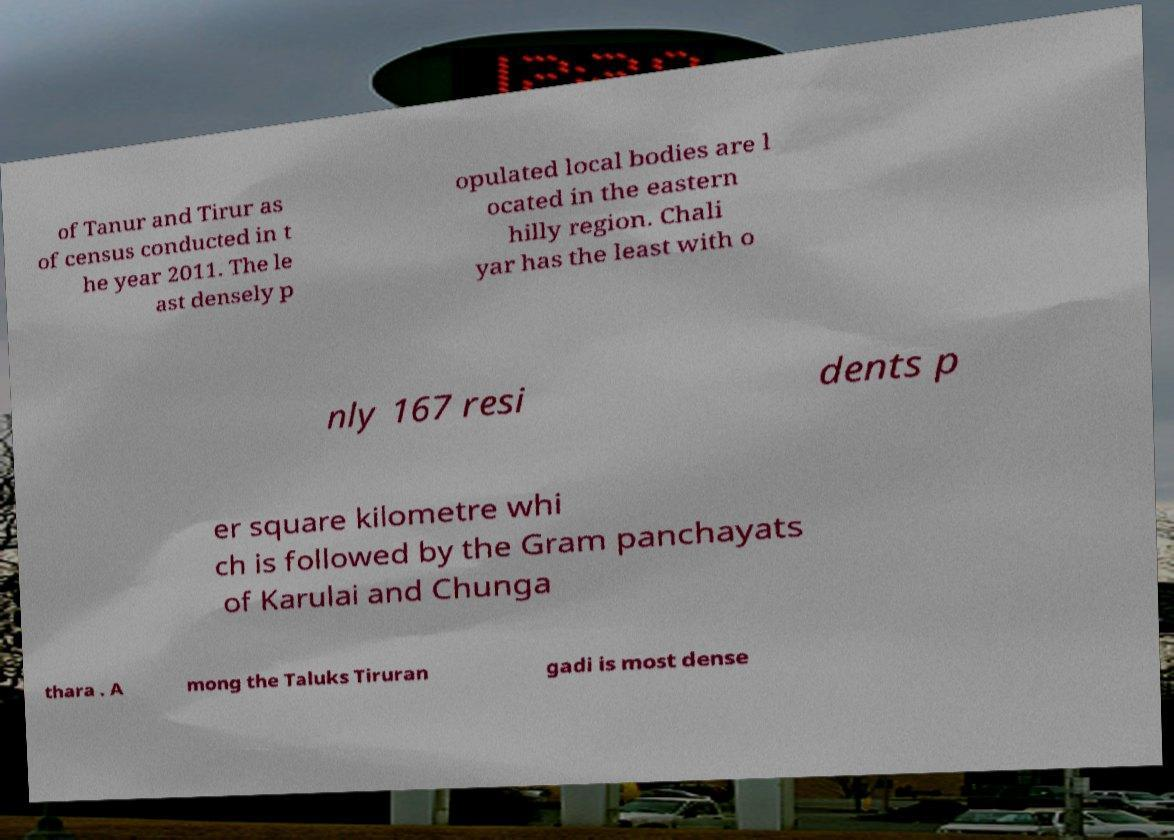I need the written content from this picture converted into text. Can you do that? of Tanur and Tirur as of census conducted in t he year 2011. The le ast densely p opulated local bodies are l ocated in the eastern hilly region. Chali yar has the least with o nly 167 resi dents p er square kilometre whi ch is followed by the Gram panchayats of Karulai and Chunga thara . A mong the Taluks Tiruran gadi is most dense 